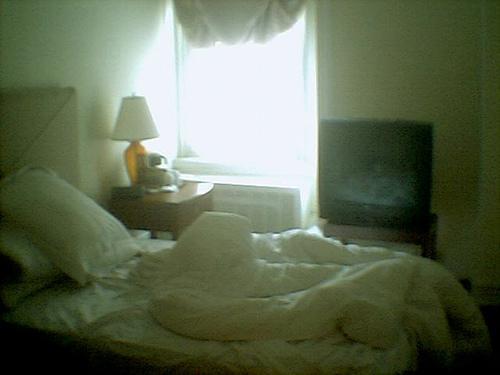How many televisions are in the picture?
Give a very brief answer. 1. How many windows are in the room?
Give a very brief answer. 1. How many lamps are on the table?
Give a very brief answer. 1. 